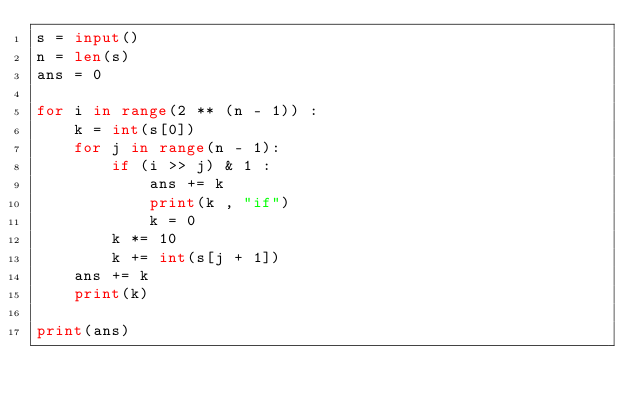<code> <loc_0><loc_0><loc_500><loc_500><_Python_>s = input()
n = len(s)
ans = 0

for i in range(2 ** (n - 1)) :
    k = int(s[0])
    for j in range(n - 1):
        if (i >> j) & 1 :
            ans += k
            print(k , "if")
            k = 0
        k *= 10
        k += int(s[j + 1])
    ans += k
    print(k)

print(ans)</code> 